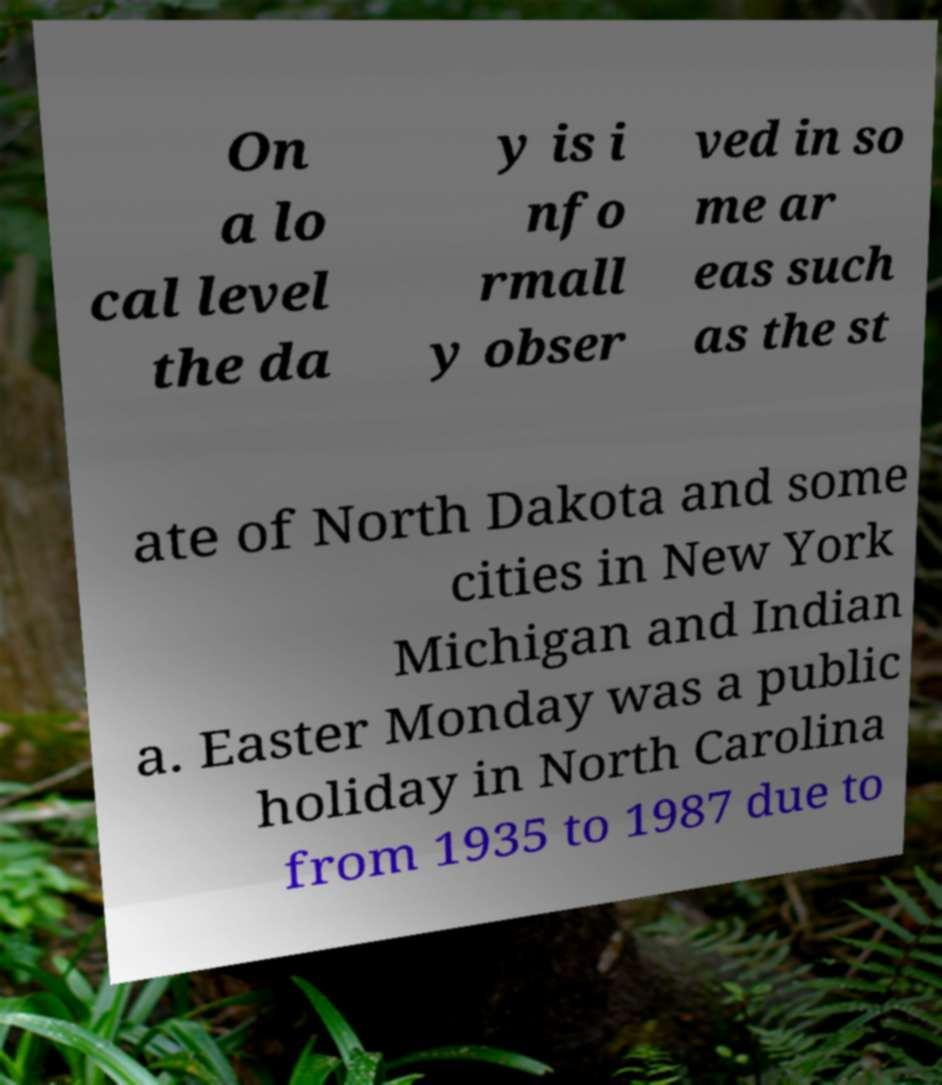There's text embedded in this image that I need extracted. Can you transcribe it verbatim? On a lo cal level the da y is i nfo rmall y obser ved in so me ar eas such as the st ate of North Dakota and some cities in New York Michigan and Indian a. Easter Monday was a public holiday in North Carolina from 1935 to 1987 due to 